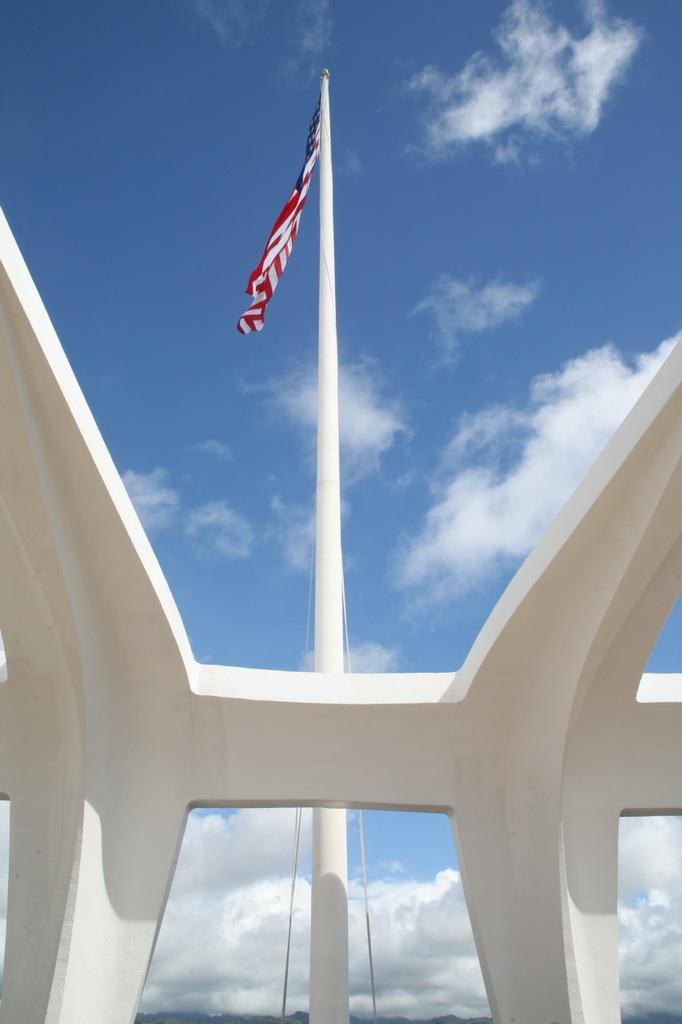What is the main object in the image? There is a flag in the image. What is attached to the flagpole? There are ropes on the flagpole. What can be seen at the top of the image? The sky is visible at the top of the image. What is the condition of the sky in the image? There are clouds in the sky. What type of crime is being committed in the image? There is no indication of any crime being committed in the image; it features a flag and clouds in the sky. Where is the middle of the earth located in the image? The image does not depict the middle of the earth; it features a flag and clouds in the sky. 